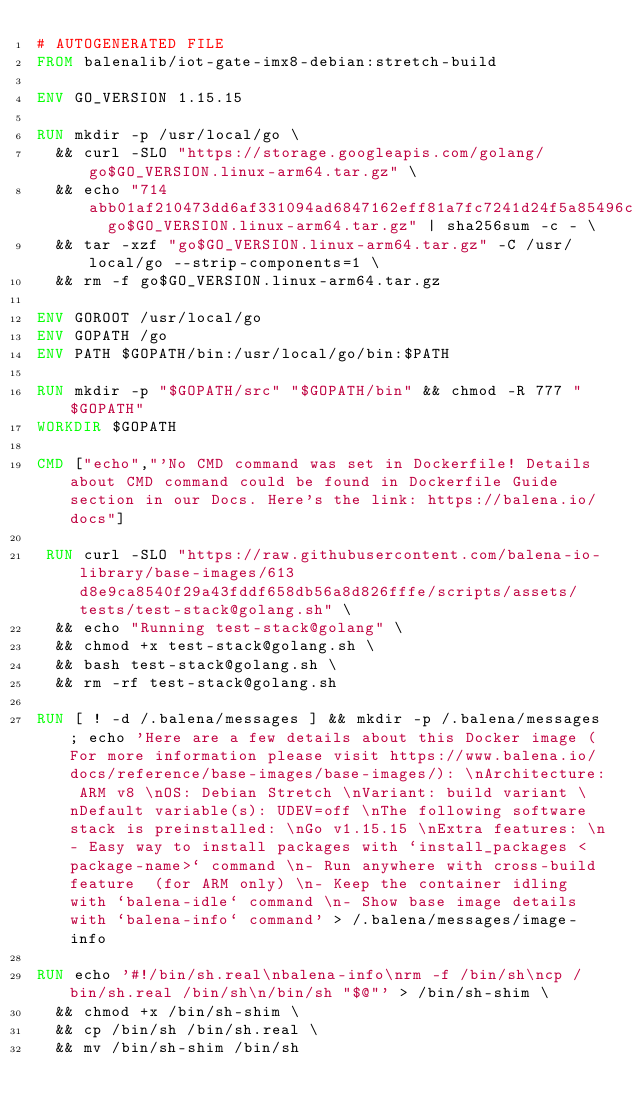<code> <loc_0><loc_0><loc_500><loc_500><_Dockerfile_># AUTOGENERATED FILE
FROM balenalib/iot-gate-imx8-debian:stretch-build

ENV GO_VERSION 1.15.15

RUN mkdir -p /usr/local/go \
	&& curl -SLO "https://storage.googleapis.com/golang/go$GO_VERSION.linux-arm64.tar.gz" \
	&& echo "714abb01af210473dd6af331094ad6847162eff81a7fc7241d24f5a85496c9fa  go$GO_VERSION.linux-arm64.tar.gz" | sha256sum -c - \
	&& tar -xzf "go$GO_VERSION.linux-arm64.tar.gz" -C /usr/local/go --strip-components=1 \
	&& rm -f go$GO_VERSION.linux-arm64.tar.gz

ENV GOROOT /usr/local/go
ENV GOPATH /go
ENV PATH $GOPATH/bin:/usr/local/go/bin:$PATH

RUN mkdir -p "$GOPATH/src" "$GOPATH/bin" && chmod -R 777 "$GOPATH"
WORKDIR $GOPATH

CMD ["echo","'No CMD command was set in Dockerfile! Details about CMD command could be found in Dockerfile Guide section in our Docs. Here's the link: https://balena.io/docs"]

 RUN curl -SLO "https://raw.githubusercontent.com/balena-io-library/base-images/613d8e9ca8540f29a43fddf658db56a8d826fffe/scripts/assets/tests/test-stack@golang.sh" \
  && echo "Running test-stack@golang" \
  && chmod +x test-stack@golang.sh \
  && bash test-stack@golang.sh \
  && rm -rf test-stack@golang.sh 

RUN [ ! -d /.balena/messages ] && mkdir -p /.balena/messages; echo 'Here are a few details about this Docker image (For more information please visit https://www.balena.io/docs/reference/base-images/base-images/): \nArchitecture: ARM v8 \nOS: Debian Stretch \nVariant: build variant \nDefault variable(s): UDEV=off \nThe following software stack is preinstalled: \nGo v1.15.15 \nExtra features: \n- Easy way to install packages with `install_packages <package-name>` command \n- Run anywhere with cross-build feature  (for ARM only) \n- Keep the container idling with `balena-idle` command \n- Show base image details with `balena-info` command' > /.balena/messages/image-info

RUN echo '#!/bin/sh.real\nbalena-info\nrm -f /bin/sh\ncp /bin/sh.real /bin/sh\n/bin/sh "$@"' > /bin/sh-shim \
	&& chmod +x /bin/sh-shim \
	&& cp /bin/sh /bin/sh.real \
	&& mv /bin/sh-shim /bin/sh</code> 